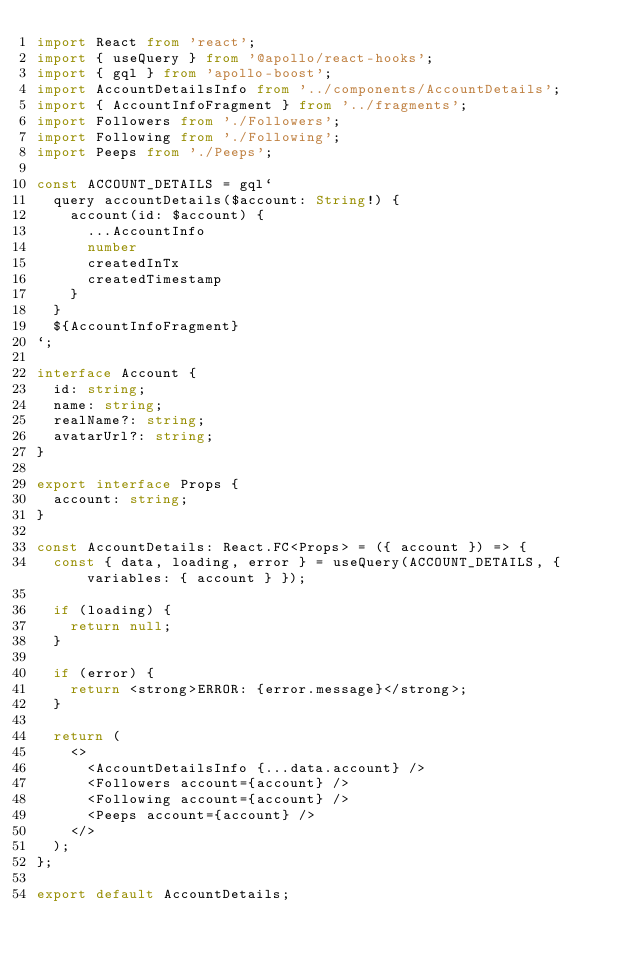Convert code to text. <code><loc_0><loc_0><loc_500><loc_500><_TypeScript_>import React from 'react';
import { useQuery } from '@apollo/react-hooks';
import { gql } from 'apollo-boost';
import AccountDetailsInfo from '../components/AccountDetails';
import { AccountInfoFragment } from '../fragments';
import Followers from './Followers';
import Following from './Following';
import Peeps from './Peeps';

const ACCOUNT_DETAILS = gql`
  query accountDetails($account: String!) {
    account(id: $account) {
      ...AccountInfo
      number
      createdInTx
      createdTimestamp
    }
  }
  ${AccountInfoFragment}
`;

interface Account {
  id: string;
  name: string;
  realName?: string;
  avatarUrl?: string;
}

export interface Props {
  account: string;
}

const AccountDetails: React.FC<Props> = ({ account }) => {
  const { data, loading, error } = useQuery(ACCOUNT_DETAILS, { variables: { account } });

  if (loading) {
    return null;
  }

  if (error) {
    return <strong>ERROR: {error.message}</strong>;
  }

  return (
    <>
      <AccountDetailsInfo {...data.account} />
      <Followers account={account} />
      <Following account={account} />
      <Peeps account={account} />
    </>
  );
};

export default AccountDetails;
</code> 